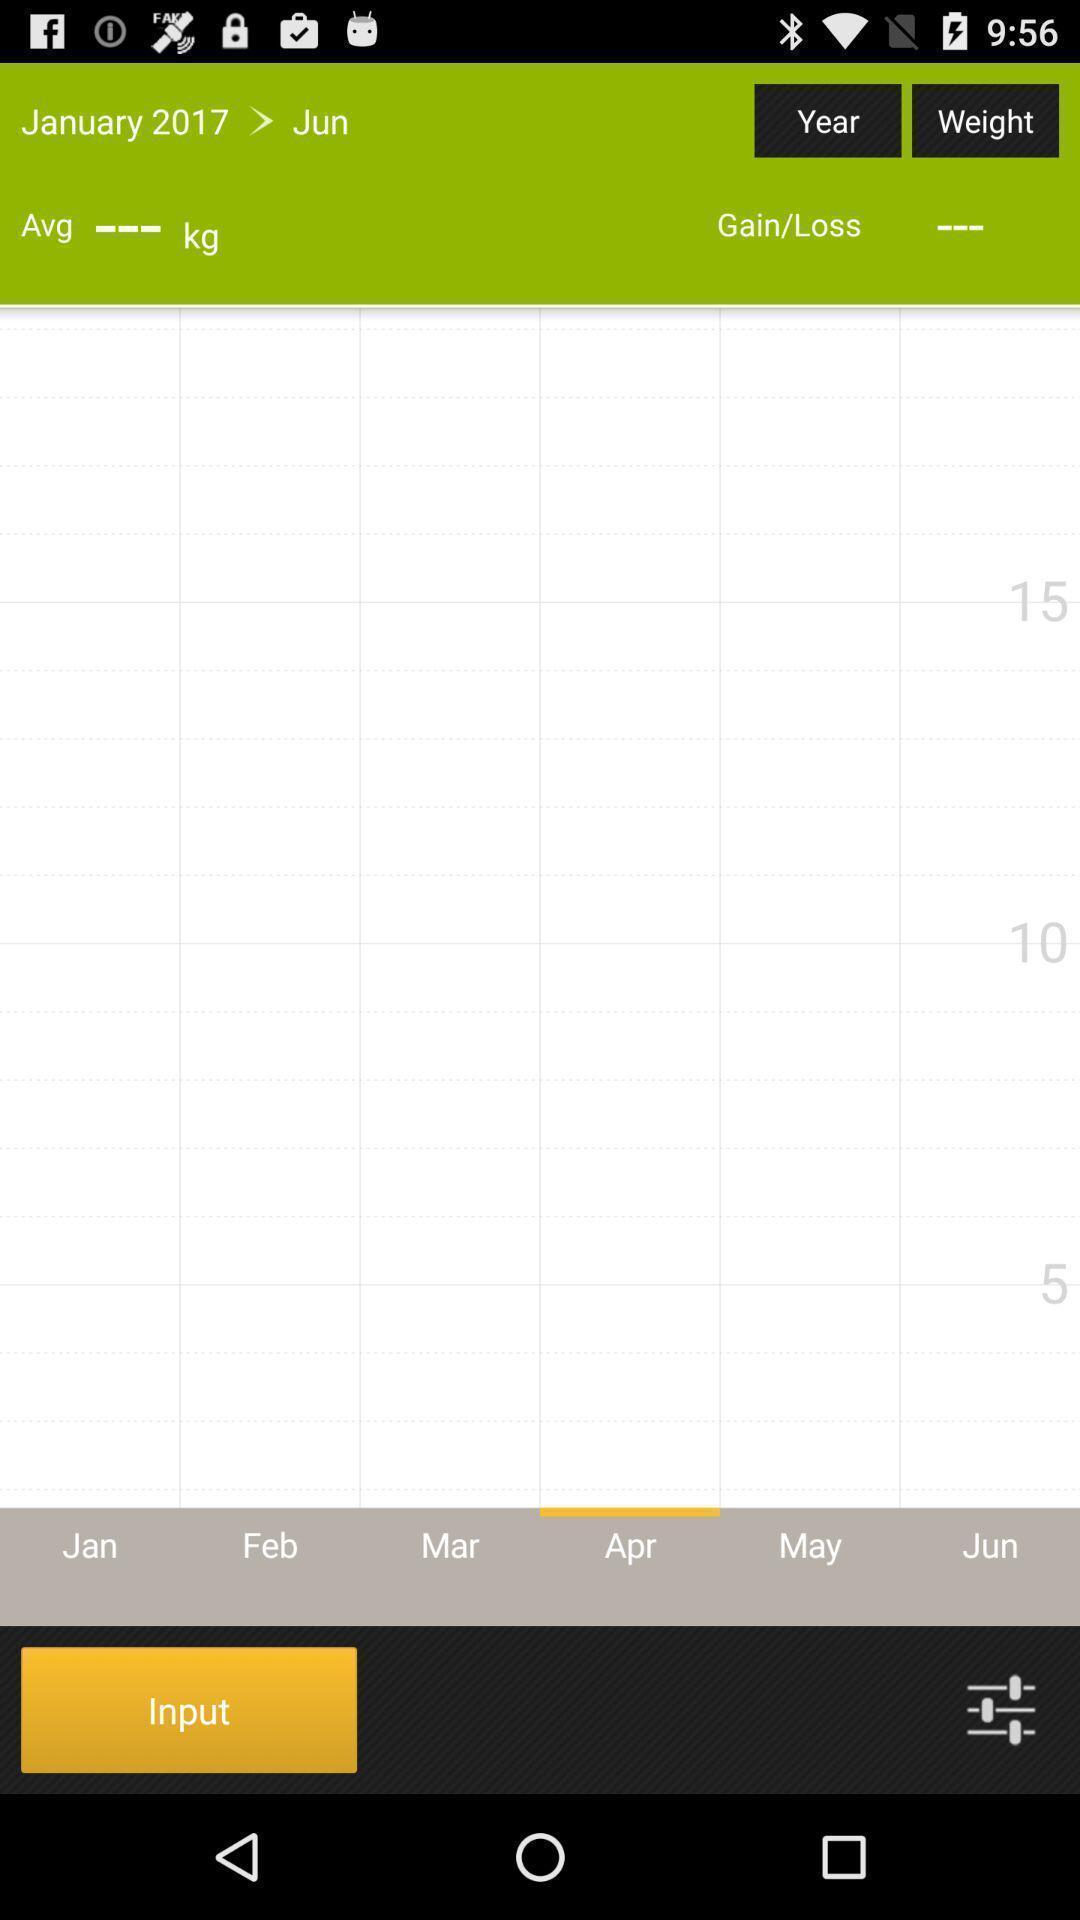Provide a textual representation of this image. Page for checking graph of body weight. 